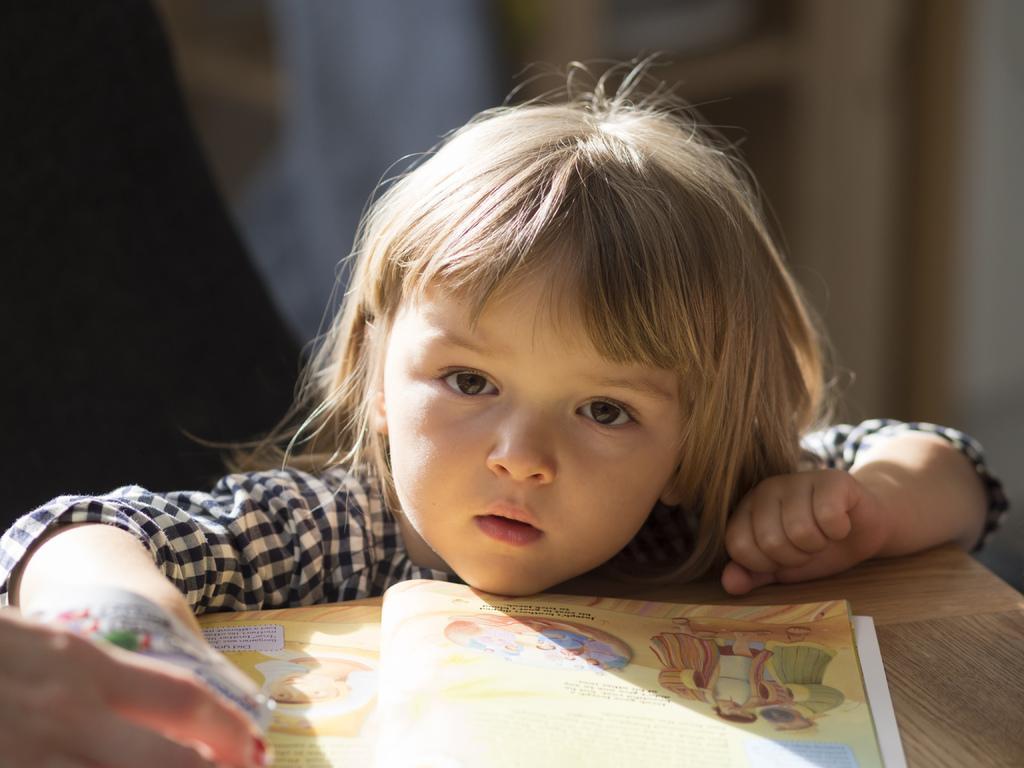In one or two sentences, can you explain what this image depicts? In this image we can see a child beside a table containing a book on it. At the bottom left we can see the hand of a person holding an object. 